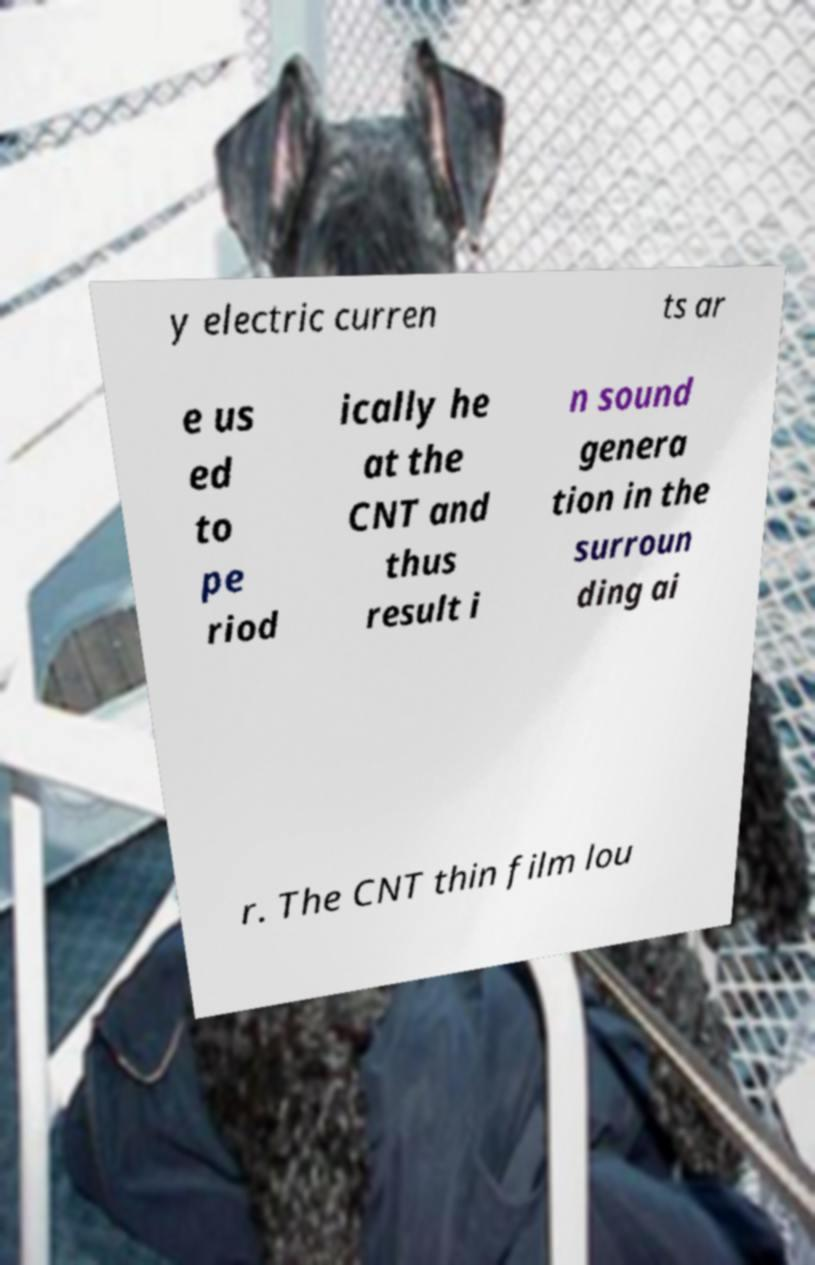I need the written content from this picture converted into text. Can you do that? y electric curren ts ar e us ed to pe riod ically he at the CNT and thus result i n sound genera tion in the surroun ding ai r. The CNT thin film lou 